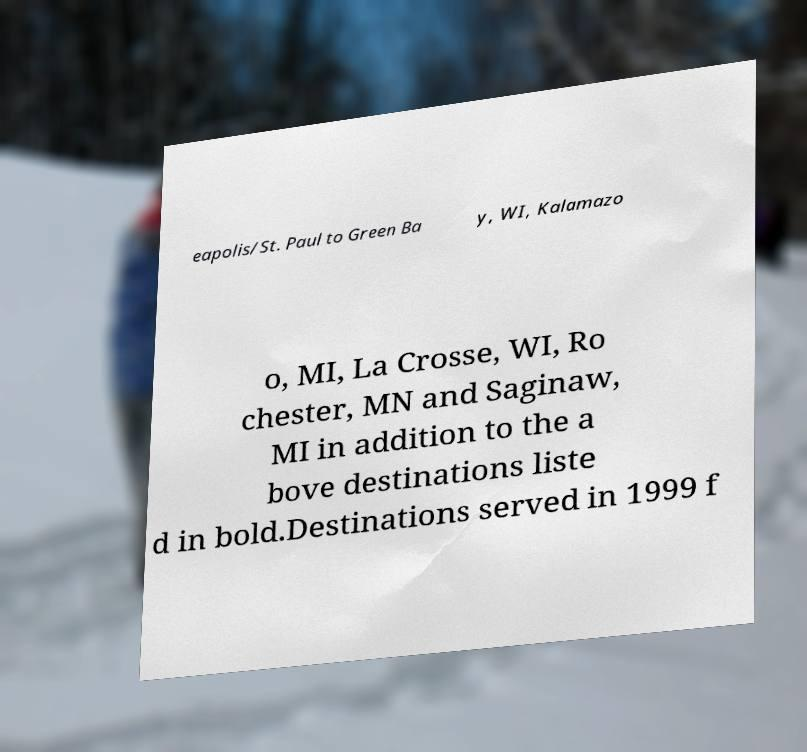I need the written content from this picture converted into text. Can you do that? eapolis/St. Paul to Green Ba y, WI, Kalamazo o, MI, La Crosse, WI, Ro chester, MN and Saginaw, MI in addition to the a bove destinations liste d in bold.Destinations served in 1999 f 